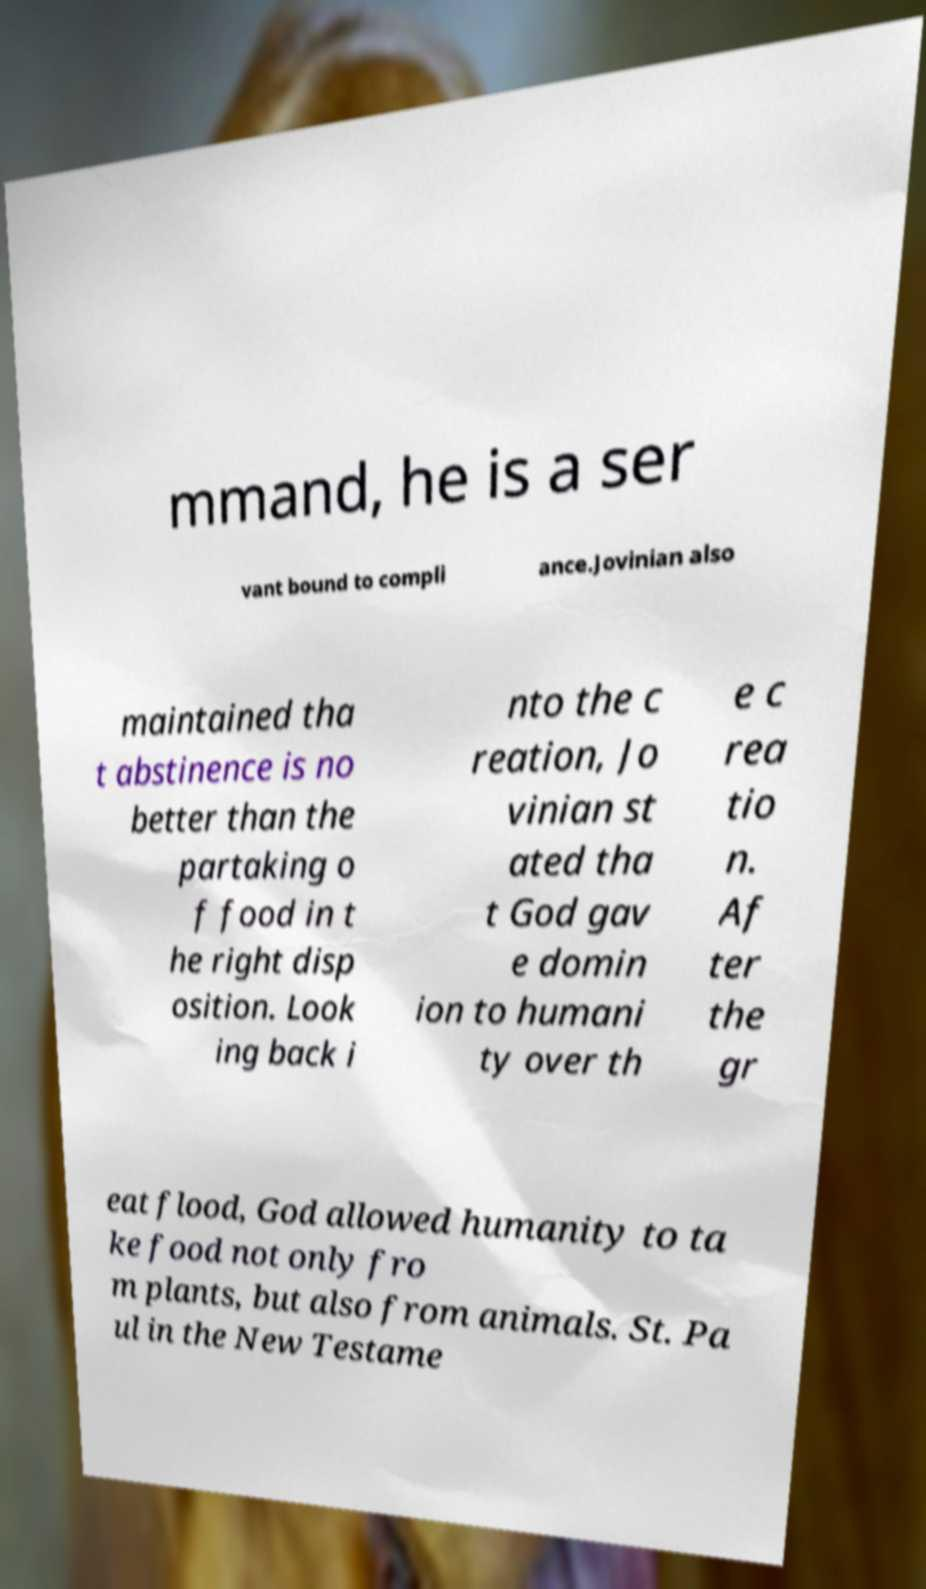Please read and relay the text visible in this image. What does it say? mmand, he is a ser vant bound to compli ance.Jovinian also maintained tha t abstinence is no better than the partaking o f food in t he right disp osition. Look ing back i nto the c reation, Jo vinian st ated tha t God gav e domin ion to humani ty over th e c rea tio n. Af ter the gr eat flood, God allowed humanity to ta ke food not only fro m plants, but also from animals. St. Pa ul in the New Testame 